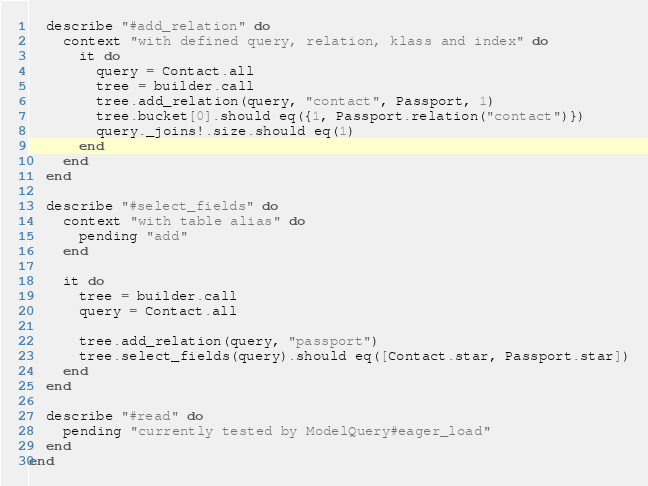<code> <loc_0><loc_0><loc_500><loc_500><_Crystal_>  describe "#add_relation" do
    context "with defined query, relation, klass and index" do
      it do
        query = Contact.all
        tree = builder.call
        tree.add_relation(query, "contact", Passport, 1)
        tree.bucket[0].should eq({1, Passport.relation("contact")})
        query._joins!.size.should eq(1)
      end
    end
  end

  describe "#select_fields" do
    context "with table alias" do
      pending "add"
    end

    it do
      tree = builder.call
      query = Contact.all

      tree.add_relation(query, "passport")
      tree.select_fields(query).should eq([Contact.star, Passport.star])
    end
  end

  describe "#read" do
    pending "currently tested by ModelQuery#eager_load"
  end
end
</code> 